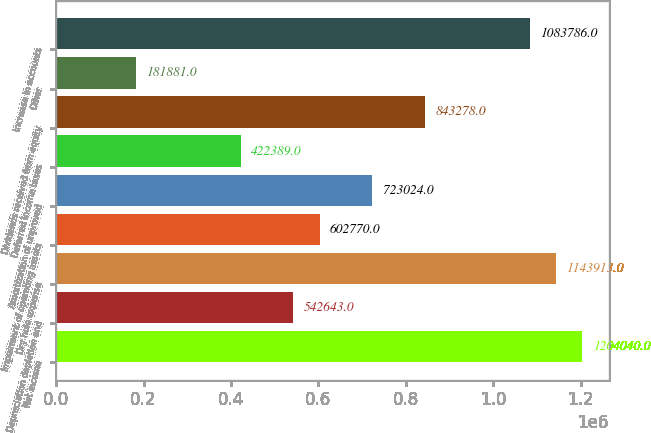Convert chart. <chart><loc_0><loc_0><loc_500><loc_500><bar_chart><fcel>Net income<fcel>Depreciation depletion and<fcel>Dry hole expense<fcel>Impairment of operating assets<fcel>Amortization of unproved<fcel>Deferred income taxes<fcel>Dividends received from equity<fcel>Other<fcel>Increase in accounts<nl><fcel>1.20404e+06<fcel>542643<fcel>1.14391e+06<fcel>602770<fcel>723024<fcel>422389<fcel>843278<fcel>181881<fcel>1.08379e+06<nl></chart> 